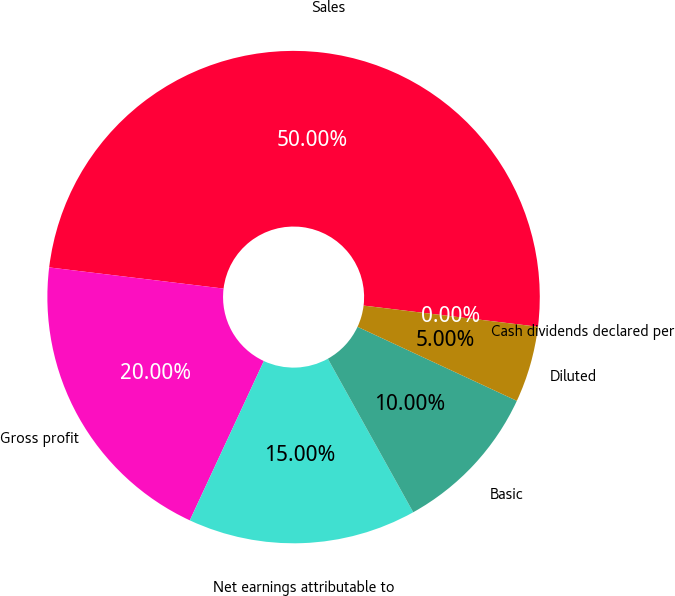<chart> <loc_0><loc_0><loc_500><loc_500><pie_chart><fcel>Sales<fcel>Gross profit<fcel>Net earnings attributable to<fcel>Basic<fcel>Diluted<fcel>Cash dividends declared per<nl><fcel>50.0%<fcel>20.0%<fcel>15.0%<fcel>10.0%<fcel>5.0%<fcel>0.0%<nl></chart> 